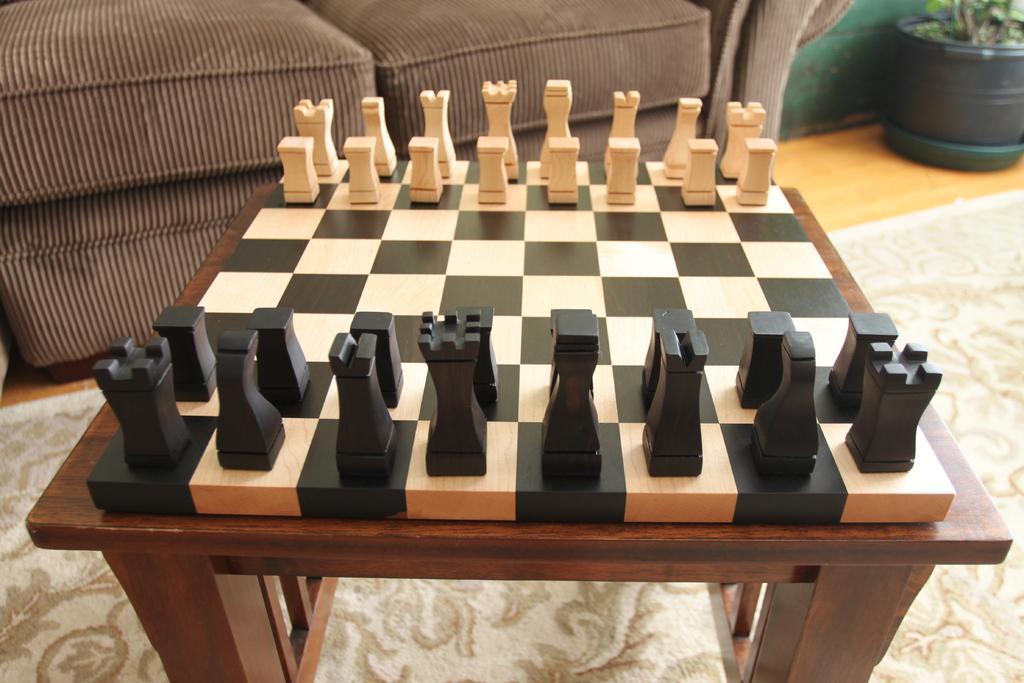Could you give a brief overview of what you see in this image? In this image in the center there is a chess board on the stool. On the right side there is a plant inside the pot which is black in colour and at the top there is a sofa. On the floor there is mat. 